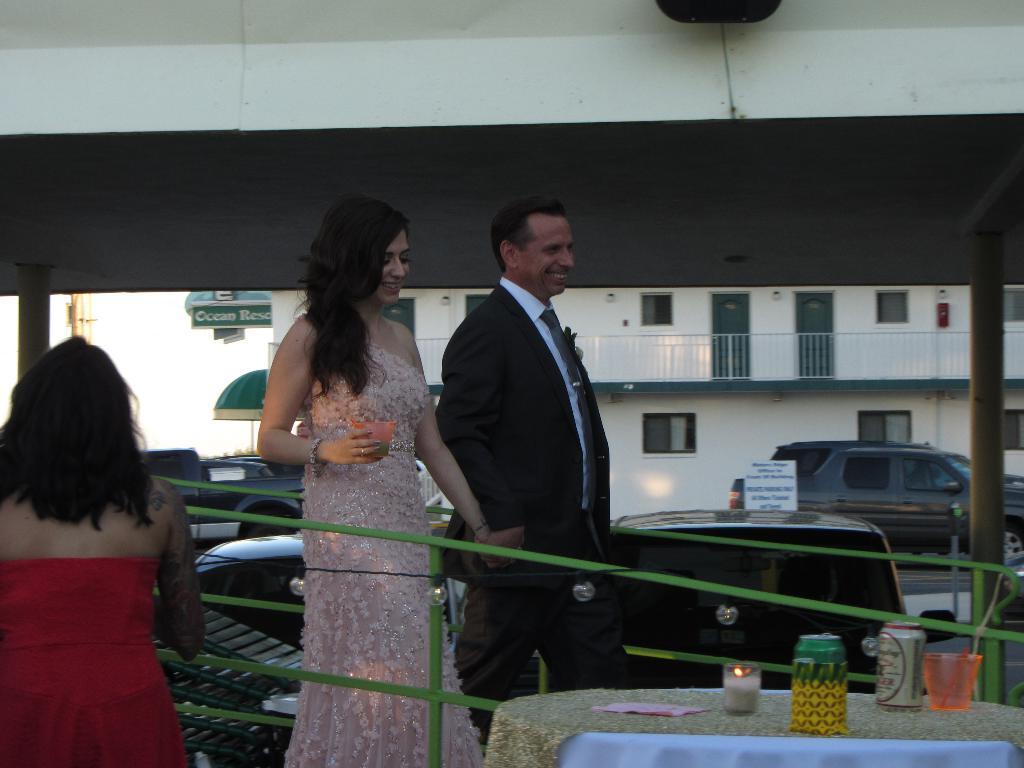Describe this image in one or two sentences. In front of the image there is a chair. There is a table. On top of it there are some objects. On the left side of the image there is a person. There is a railing. There are two people holding their hands and they are having a smile on their faces. Behind them there are cars. There are boards with some text on it. In the background of the image there is a building and there is a tent. 